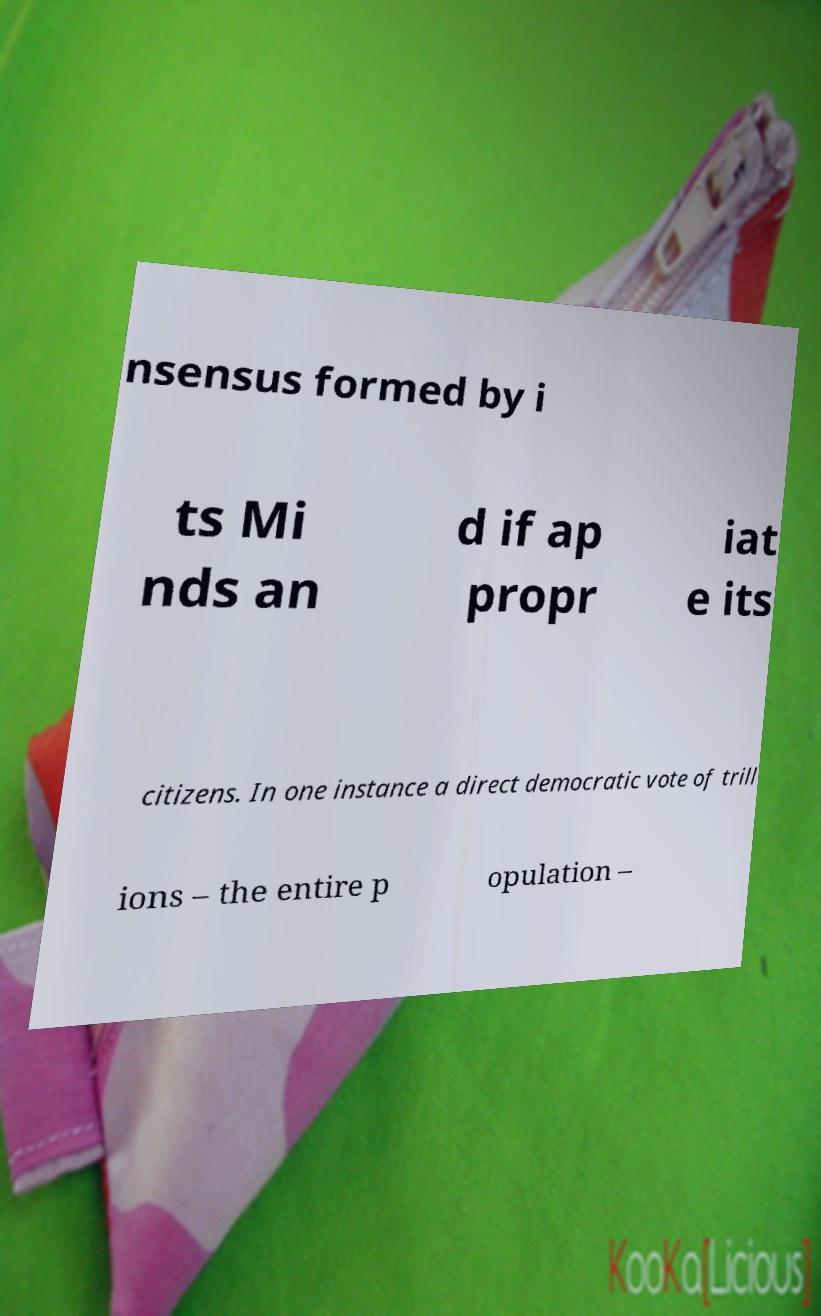Can you accurately transcribe the text from the provided image for me? nsensus formed by i ts Mi nds an d if ap propr iat e its citizens. In one instance a direct democratic vote of trill ions – the entire p opulation – 